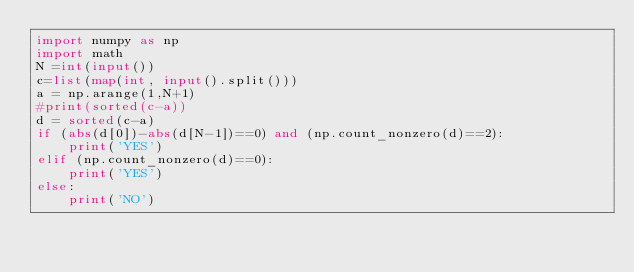Convert code to text. <code><loc_0><loc_0><loc_500><loc_500><_Python_>import numpy as np
import math
N =int(input())
c=list(map(int, input().split())) 
a = np.arange(1,N+1)
#print(sorted(c-a))
d = sorted(c-a)
if (abs(d[0])-abs(d[N-1])==0) and (np.count_nonzero(d)==2):
    print('YES')
elif (np.count_nonzero(d)==0):
    print('YES')
else:
    print('NO')

</code> 